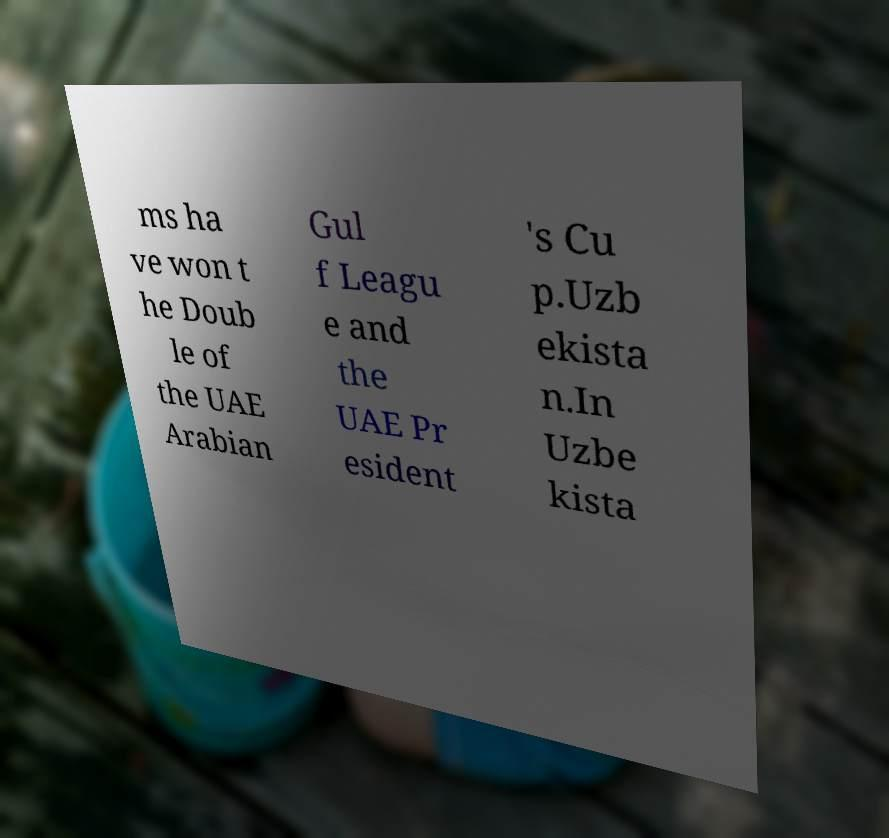What messages or text are displayed in this image? I need them in a readable, typed format. ms ha ve won t he Doub le of the UAE Arabian Gul f Leagu e and the UAE Pr esident 's Cu p.Uzb ekista n.In Uzbe kista 